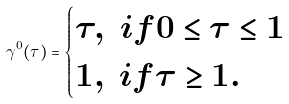Convert formula to latex. <formula><loc_0><loc_0><loc_500><loc_500>\gamma ^ { 0 } ( \tau ) = \begin{cases} \tau , \ i f 0 \leq \tau \leq 1 \\ 1 , \ i f \tau \geq 1 . \end{cases}</formula> 